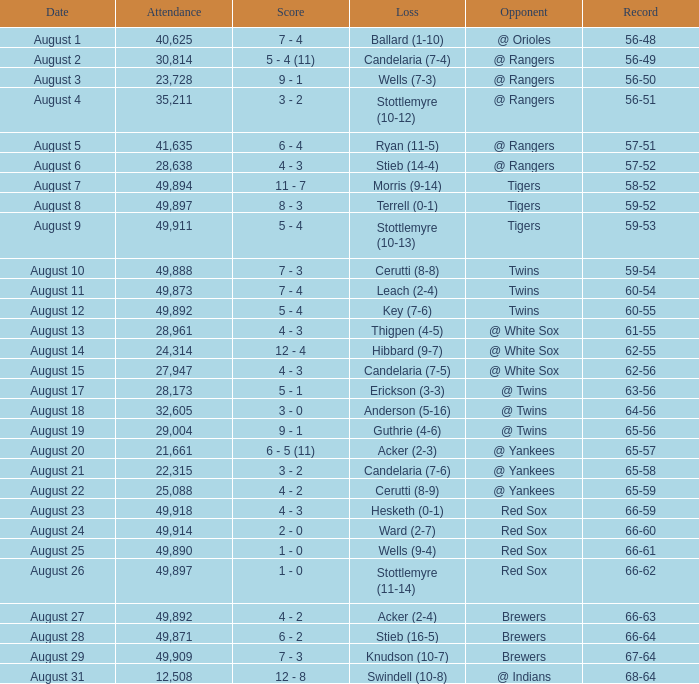What was the record of the game that had a loss of Stottlemyre (10-12)? 56-51. 